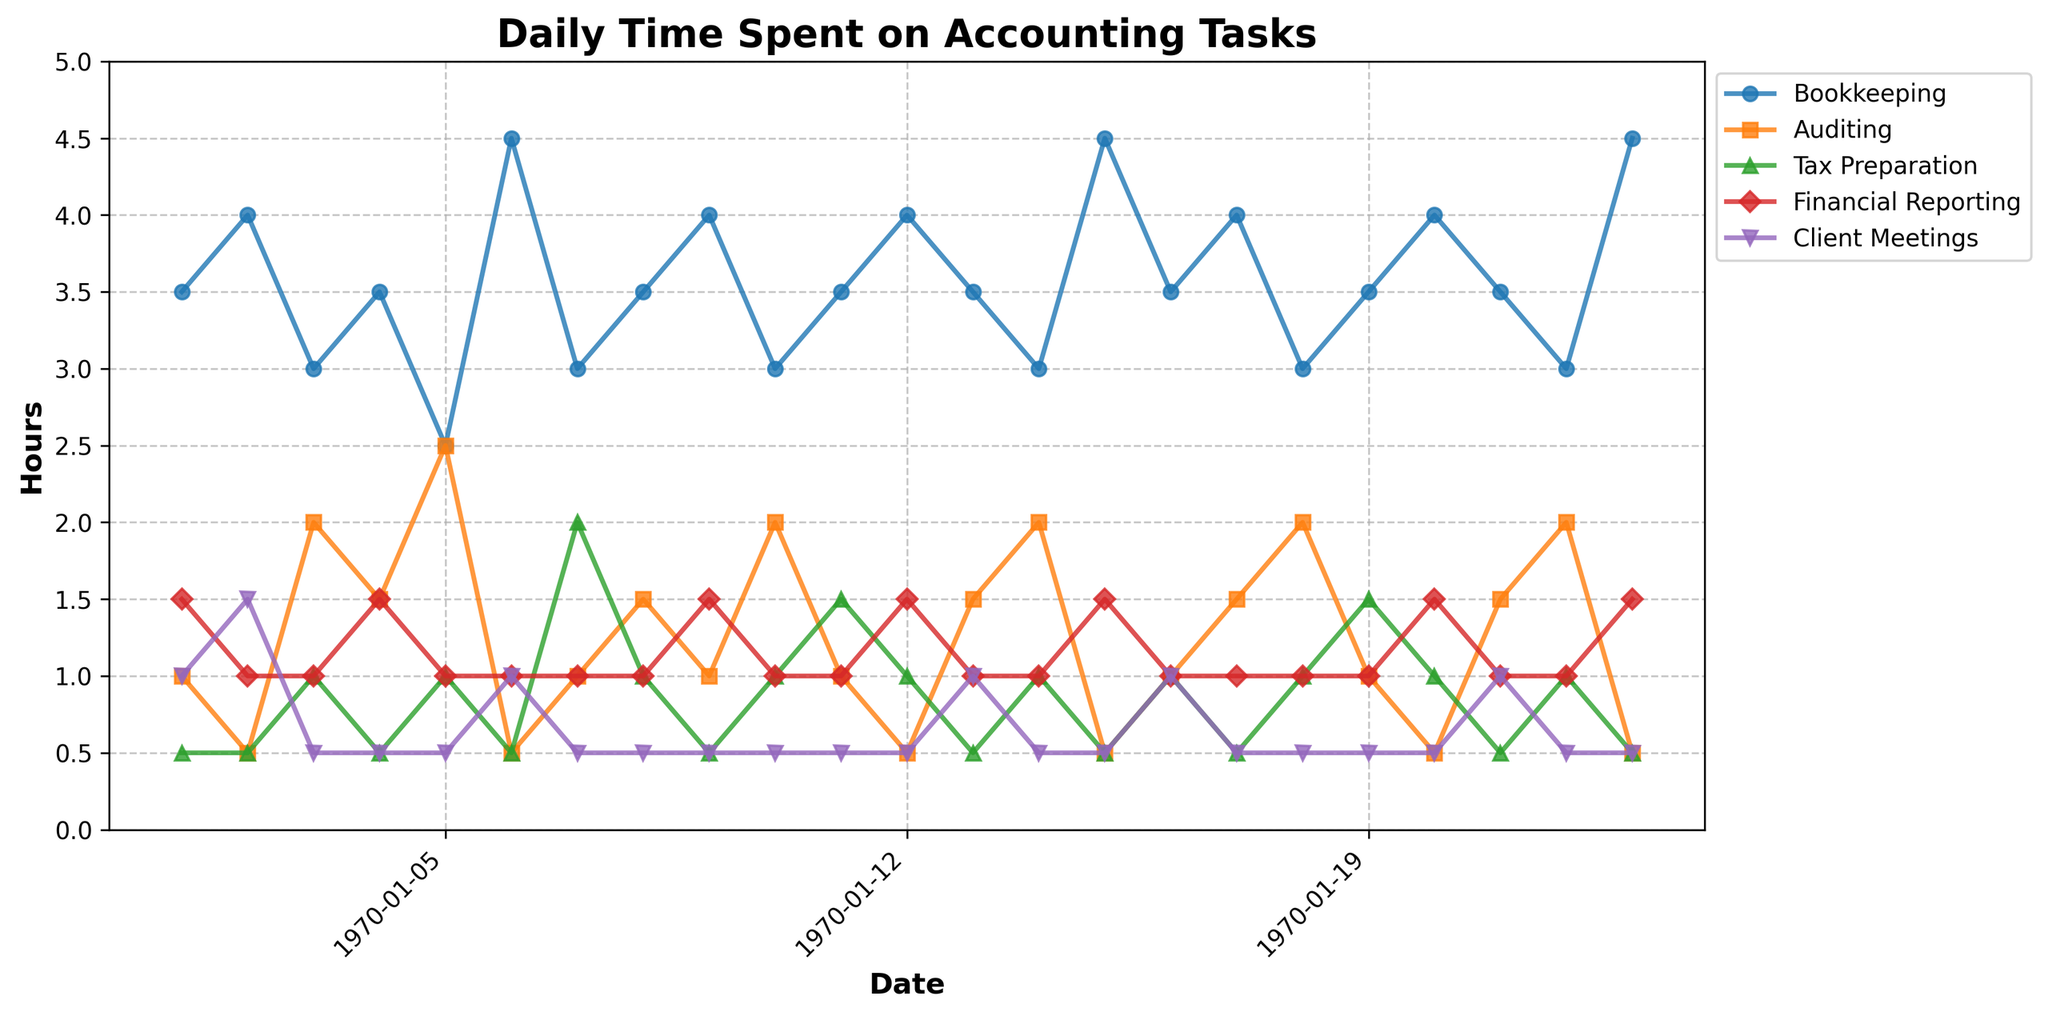What task has the most stable time allocation throughout the month? By looking at the trends, "Bookkeeping" shows the least fluctuation in daily hours throughout the month compared to the other tasks which show more variation.
Answer: Bookkeeping How does the time spent on Auditing compare on the 5th of May and the 8th of May? On the 5th of May, 2.5 hours were spent on Auditing. On the 8th of May, only 0.5 hours were spent. Subtracting these values gives a difference of 2 hours.
Answer: 2 hours more on May 5th On which day was the most time spent on Tax Preparation, and how much was it? By identifying the peak in the Tax Preparation line, the highest value appears on May 9th, where 2 hours were spent on Tax Preparation.
Answer: May 9th, 2 hours Compare the total time spent on Financial Reporting and Client Meetings on May 4th. On May 4th, 1.5 hours are spent on Financial Reporting and 0.5 hours on Client Meetings. The total time is the sum: 1.5 + 0.5 = 2 hours.
Answer: 2 hours On which date did Bookkeeping exceed 4 hours and how often did this happen in the month? Bookkeeping exceeded 4 hours on May 2nd, May 8th, May 19th, and May 31st. This happened 4 times.
Answer: 4 times What is the average time spent on Financial Reporting over the month? Add up all daily times for Financial Reporting and divide by the number of days recorded (23 days): (1.5+1+1+1.5+1+1+1+1+1.5+1+1+1+1.5+1+1+1+1+1+1.5+1+1+1+1.5)/23. The sum is 23, so the average is 23/23 = 1 hour.
Answer: 1 hour What's the total time spent on Client Meetings in the last week of the month (May 22 - May 31)? Sum the values for Client Meetings from May 22 to May 31: 1.0 + 0.5 + 0.5 + 0.5 + 0.5 + 1.0 + 0.5 + 1.0 + 0.5 = 5.5 hours.
Answer: 5.5 hours Did Auditing or Tax Preparation have more variability in time spent throughout the month? To determine variability, look at the range of values. Auditing varies from 0.5 to 2.5 hours with a range of 2.0 hours. Tax Preparation varies from 0.5 to 2.0 hours with a range of 1.5 hours. Auditing has more variability.
Answer: Auditing What is the combined time spent on Bookkeeping and Financial Reporting on May 12th? On May 12th, 3 hours are spent on Bookkeeping and 1 hour on Financial Reporting. Combined time is 3 + 1 = 4 hours.
Answer: 4 hours Which task had the lowest sum of hours over the entire month and what was this sum? Summing the hours for each task throughout the month: 
- Bookkeeping = 79.5
- Auditing = 26
- Tax Preparation = 17.5
- Financial Reporting = 23
- Client Meetings = 13.5
Client Meetings had the lowest sum of 13.5 hours.
Answer: Client Meetings, 13.5 hours 